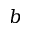<formula> <loc_0><loc_0><loc_500><loc_500>b</formula> 